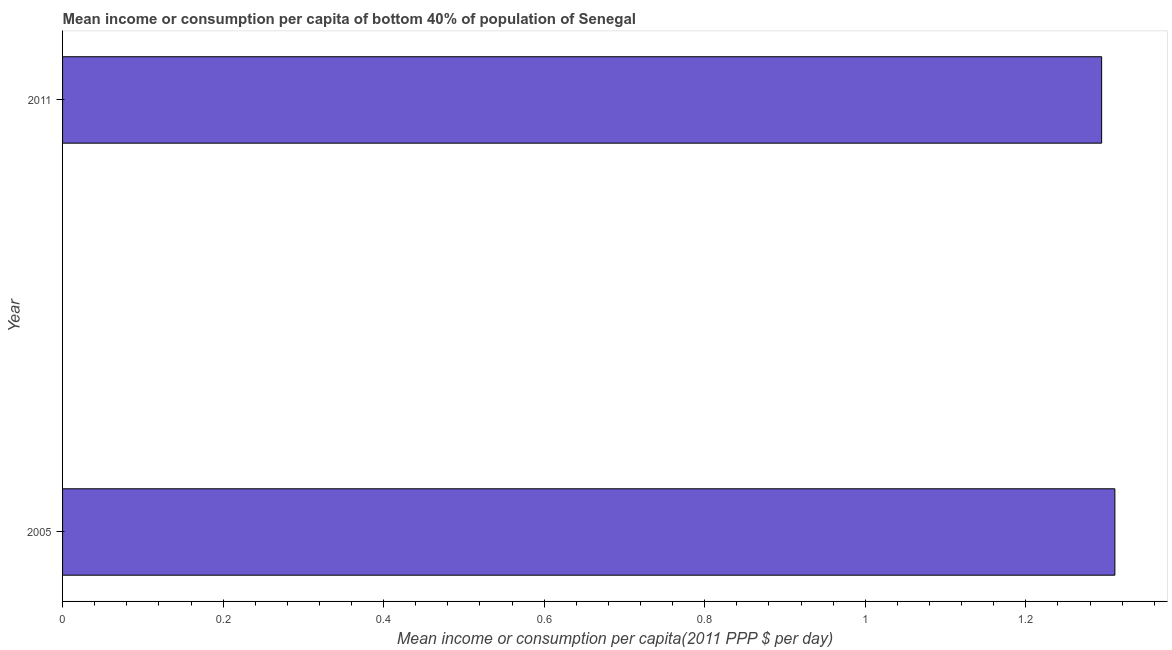Does the graph contain any zero values?
Your answer should be very brief. No. What is the title of the graph?
Provide a succinct answer. Mean income or consumption per capita of bottom 40% of population of Senegal. What is the label or title of the X-axis?
Offer a terse response. Mean income or consumption per capita(2011 PPP $ per day). What is the label or title of the Y-axis?
Ensure brevity in your answer.  Year. What is the mean income or consumption in 2005?
Ensure brevity in your answer.  1.31. Across all years, what is the maximum mean income or consumption?
Your answer should be very brief. 1.31. Across all years, what is the minimum mean income or consumption?
Your response must be concise. 1.29. In which year was the mean income or consumption minimum?
Your answer should be compact. 2011. What is the sum of the mean income or consumption?
Offer a terse response. 2.61. What is the difference between the mean income or consumption in 2005 and 2011?
Your answer should be compact. 0.02. What is the average mean income or consumption per year?
Provide a succinct answer. 1.3. What is the median mean income or consumption?
Your answer should be very brief. 1.3. What is the ratio of the mean income or consumption in 2005 to that in 2011?
Keep it short and to the point. 1.01. What is the Mean income or consumption per capita(2011 PPP $ per day) in 2005?
Keep it short and to the point. 1.31. What is the Mean income or consumption per capita(2011 PPP $ per day) of 2011?
Offer a terse response. 1.29. What is the difference between the Mean income or consumption per capita(2011 PPP $ per day) in 2005 and 2011?
Your answer should be compact. 0.02. 